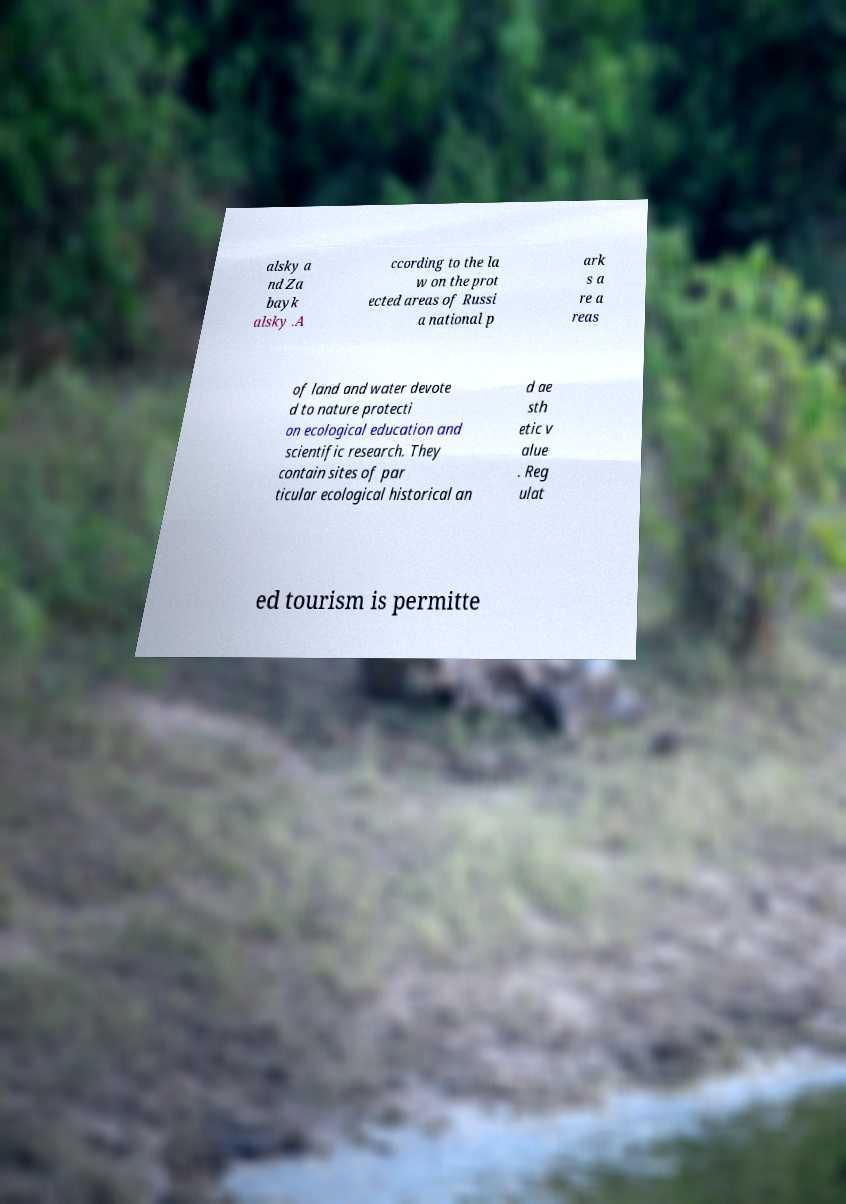Can you accurately transcribe the text from the provided image for me? alsky a nd Za bayk alsky .A ccording to the la w on the prot ected areas of Russi a national p ark s a re a reas of land and water devote d to nature protecti on ecological education and scientific research. They contain sites of par ticular ecological historical an d ae sth etic v alue . Reg ulat ed tourism is permitte 